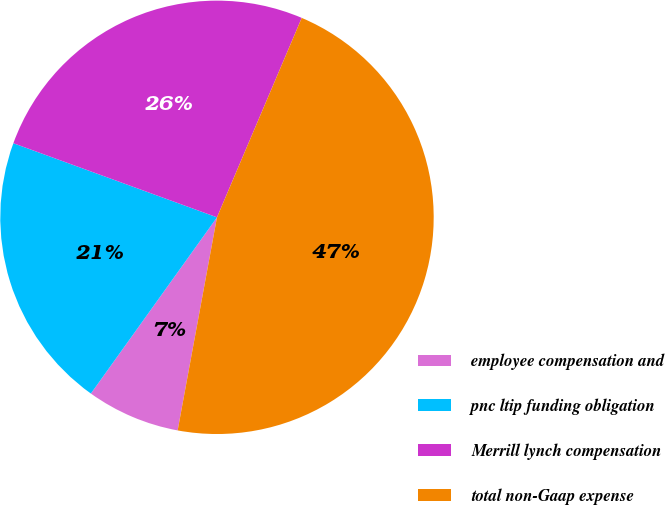Convert chart. <chart><loc_0><loc_0><loc_500><loc_500><pie_chart><fcel>employee compensation and<fcel>pnc ltip funding obligation<fcel>Merrill lynch compensation<fcel>total non-Gaap expense<nl><fcel>6.98%<fcel>20.67%<fcel>25.84%<fcel>46.51%<nl></chart> 